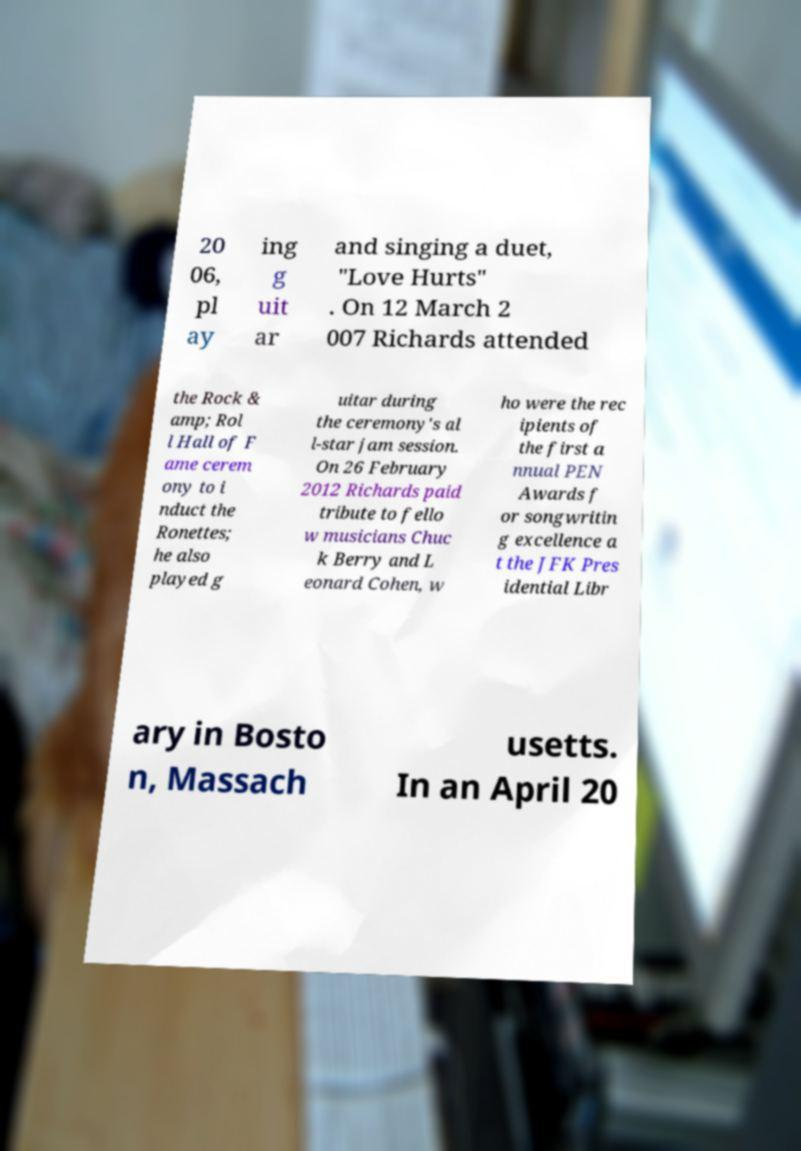For documentation purposes, I need the text within this image transcribed. Could you provide that? 20 06, pl ay ing g uit ar and singing a duet, "Love Hurts" . On 12 March 2 007 Richards attended the Rock & amp; Rol l Hall of F ame cerem ony to i nduct the Ronettes; he also played g uitar during the ceremony's al l-star jam session. On 26 February 2012 Richards paid tribute to fello w musicians Chuc k Berry and L eonard Cohen, w ho were the rec ipients of the first a nnual PEN Awards f or songwritin g excellence a t the JFK Pres idential Libr ary in Bosto n, Massach usetts. In an April 20 